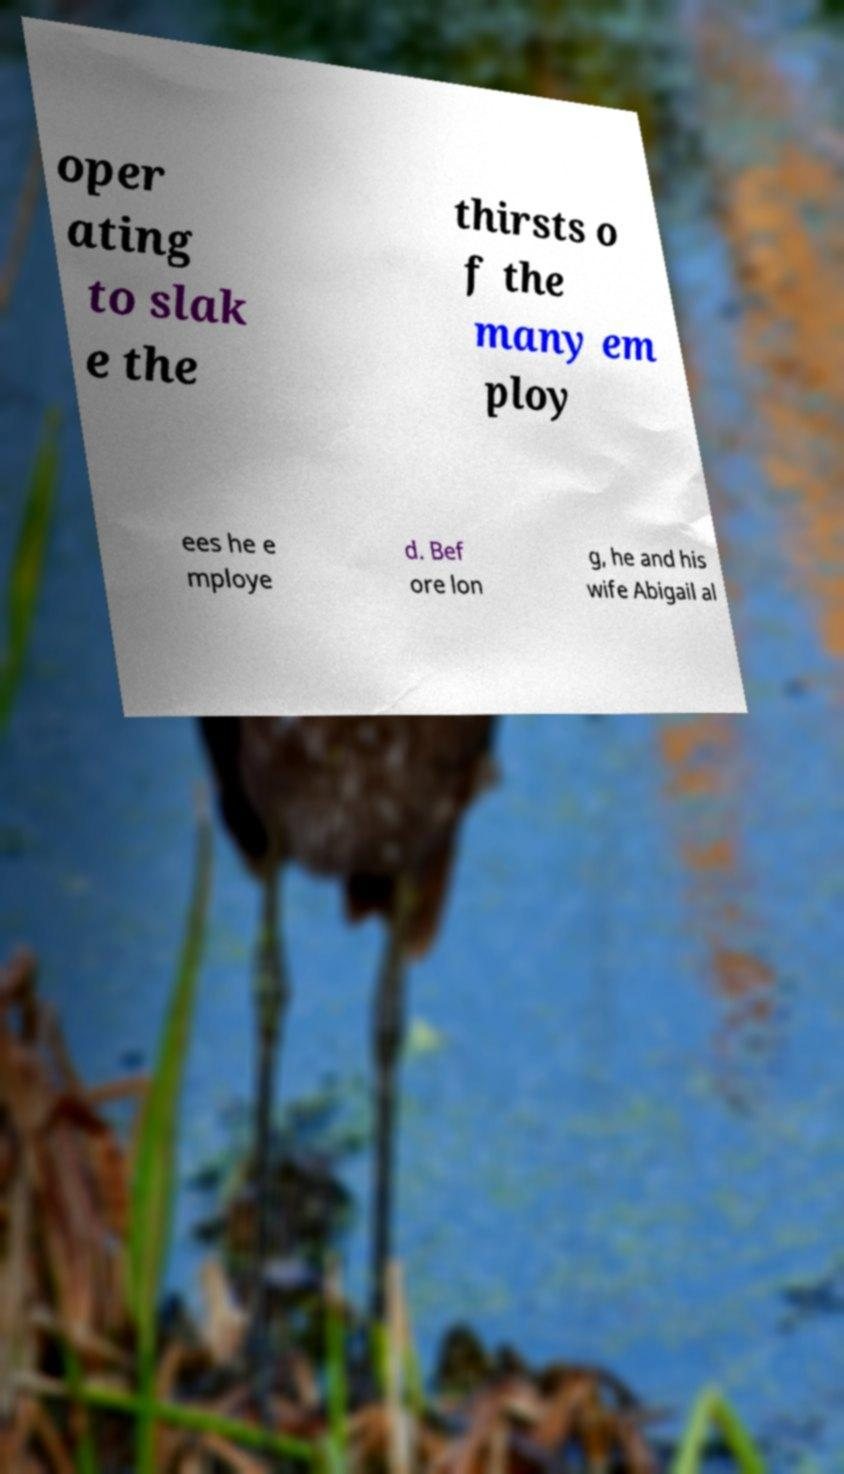Can you accurately transcribe the text from the provided image for me? oper ating to slak e the thirsts o f the many em ploy ees he e mploye d. Bef ore lon g, he and his wife Abigail al 